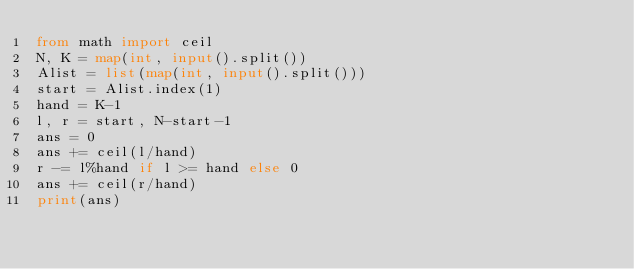Convert code to text. <code><loc_0><loc_0><loc_500><loc_500><_Python_>from math import ceil
N, K = map(int, input().split())
Alist = list(map(int, input().split()))
start = Alist.index(1)
hand = K-1
l, r = start, N-start-1
ans = 0
ans += ceil(l/hand)
r -= l%hand if l >= hand else 0
ans += ceil(r/hand)
print(ans)</code> 